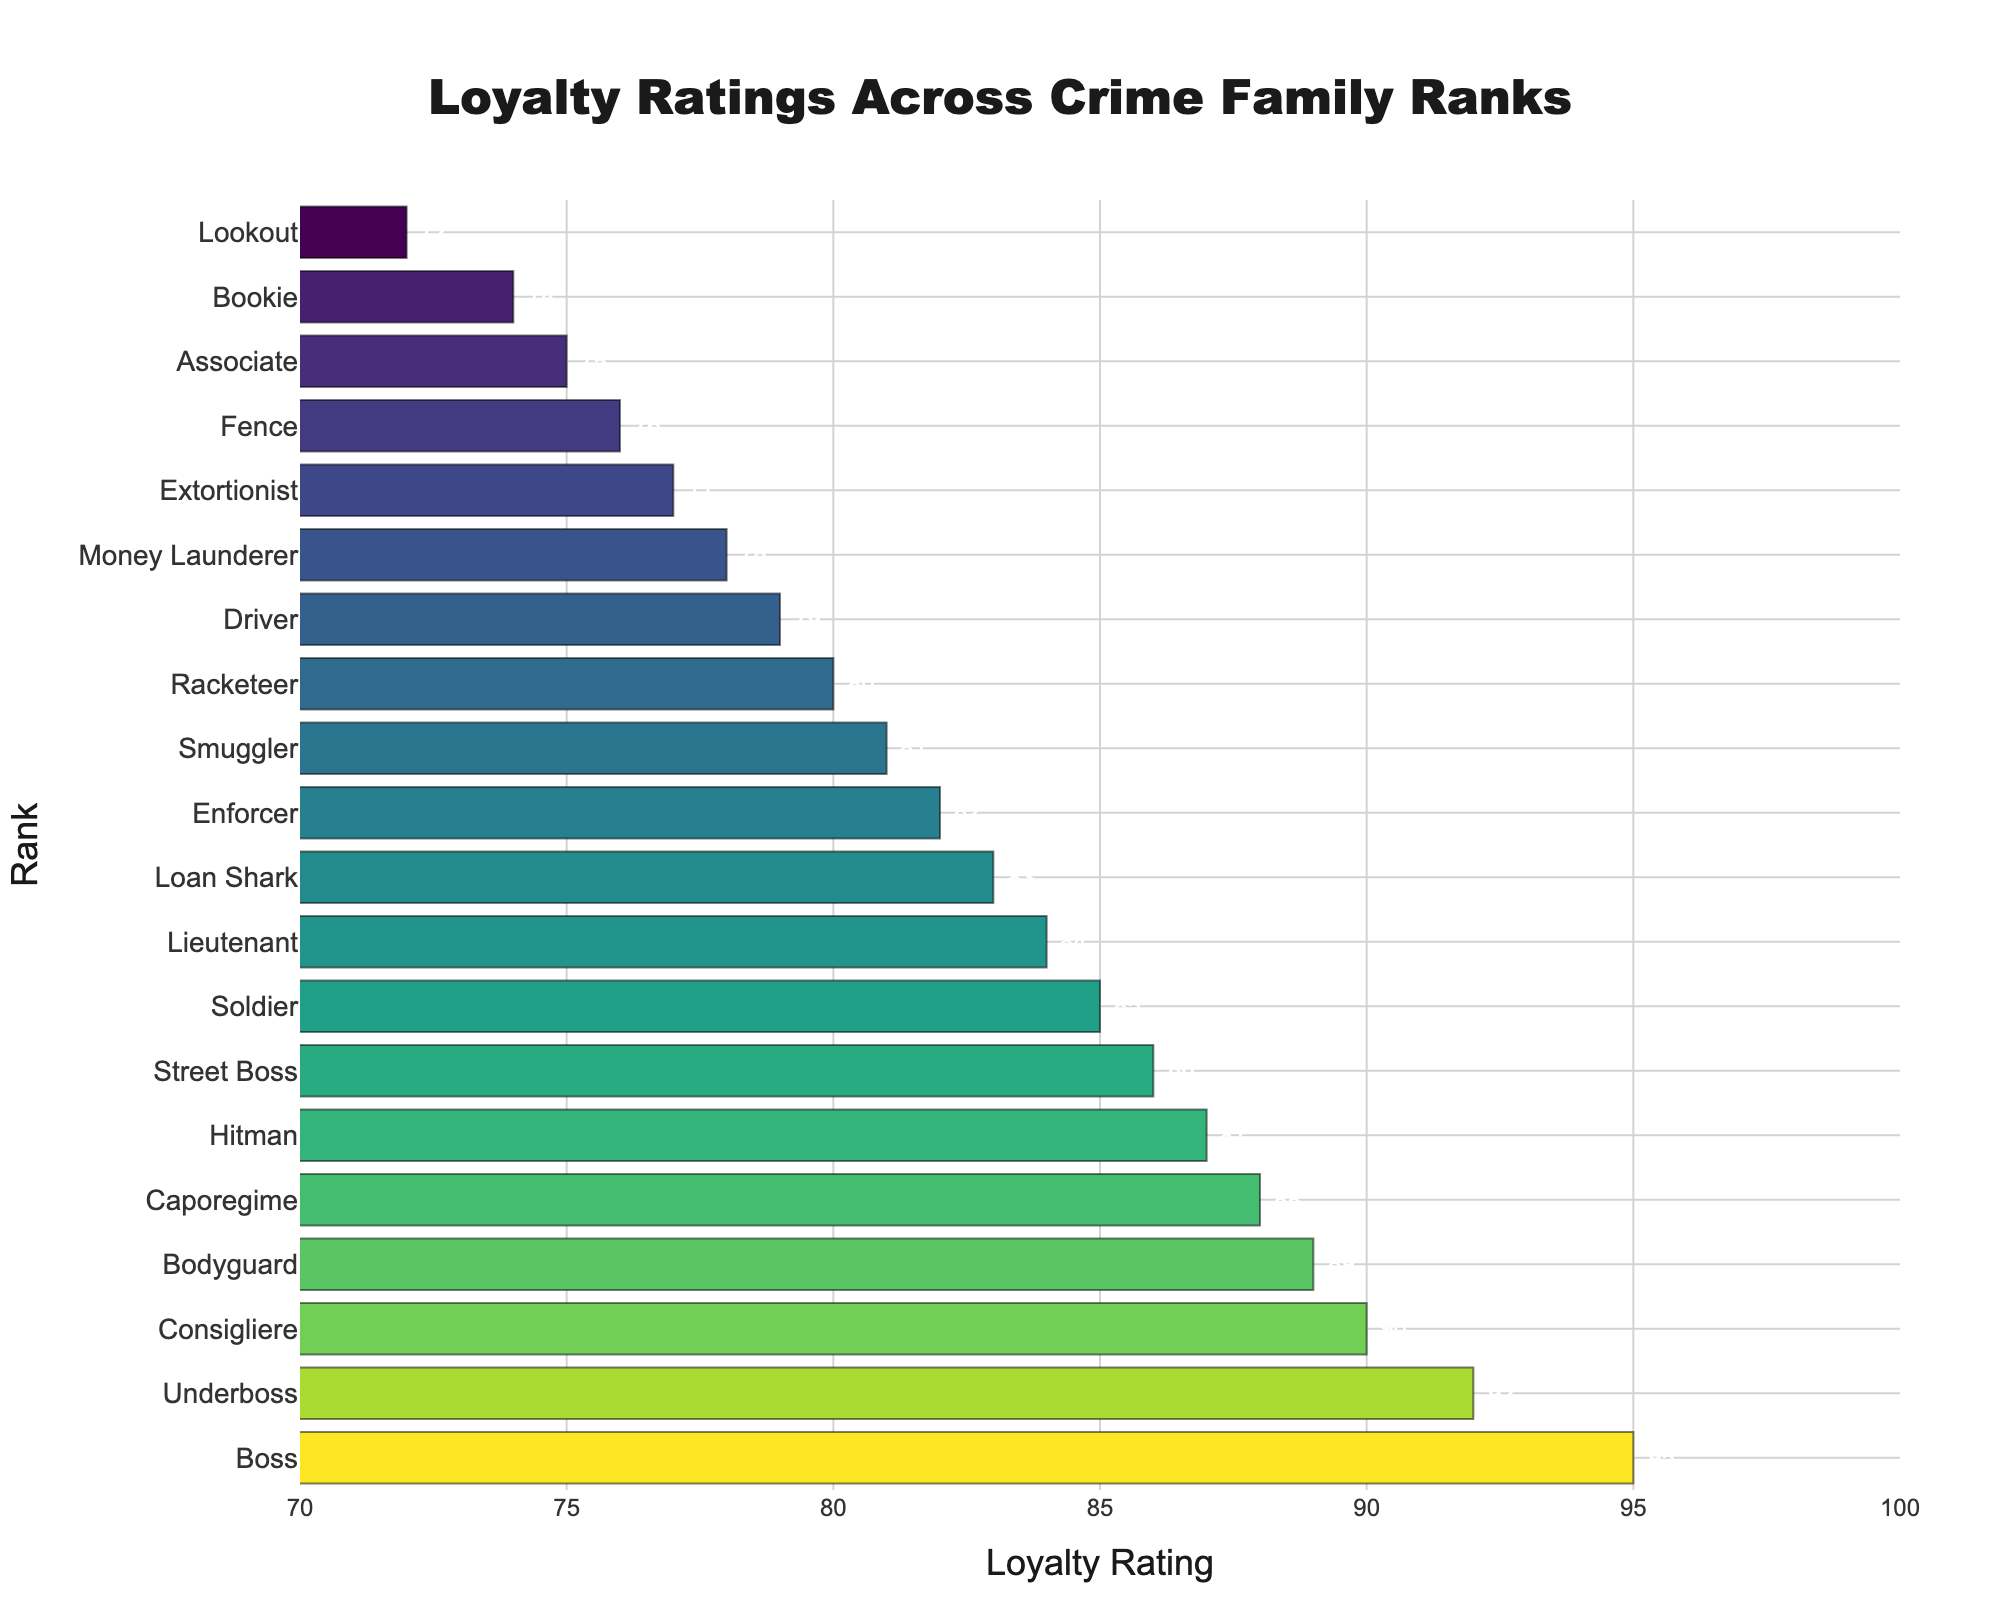What rank has the highest loyalty rating? The chart visually shows bars representing loyalty ratings, with the "Boss" having the tallest bar on the right end.
Answer: Boss Which rank has the lowest loyalty rating? The "Lookout" rank is represented by the shortest bar on the left side of the chart.
Answer: Lookout What is the difference in loyalty ratings between the Boss and the Associate? The Boss has a loyalty rating of 95, and the Associate has 75. Subtracting these values gives 95 - 75 = 20.
Answer: 20 Which rank has a higher loyalty rating: Caporegime or Street Boss? The Caporegime has a loyalty rating of 88 and the Street Boss has 86. Therefore, 88 is greater than 86.
Answer: Caporegime What is the average loyalty rating of the ranks Underboss, Consigliere, and Bodyguard? Add the loyalty ratings of Underboss (92), Consigliere (90), and Bodyguard (89), then divide by 3. (92 + 90 + 89) = 271, so the average is 271 / 3 = 90.33
Answer: 90.33 By how much does the loyalty rating of the Enforcer fall short of the Boss? The Boss has a rating of 95, and the Enforcer has 82. Subtracting these gives 95 - 82 = 13.
Answer: 13 Which ranks have loyalty ratings between 80 and 85 inclusive? Visual inspection shows bars for Soldier (85), Lieutenant (84), Loan Shark (83), Smuggler (81), and Racketeer (80) within the 80-85 range.
Answer: Soldier, Lieutenant, Loan Shark, Smuggler, Racketeer Is the loyalty rating of the Driver higher or lower than the Hitman? The Driver has a rating of 79, whereas the Hitman has 87. Thus, the Driver's rating is lower than the Hitman's.
Answer: Lower Which rank's loyalty rating is closest to the median value in the data? With 20 ranks, the median will be between the 10th and 11th values. Arranging the loyalty ratings, the 10th and 11th are 82 (Enforcer) and 83 (Loan Shark), so the median is (82 + 83) / 2 = 82.5. Hence, Enforcer is closest to this value.
Answer: Enforcer 